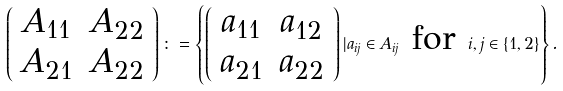Convert formula to latex. <formula><loc_0><loc_0><loc_500><loc_500>\left ( \begin{array} { c c } A _ { 1 1 } & A _ { 2 2 } \\ A _ { 2 1 } & A _ { 2 2 } \end{array} \right ) \colon = \left \{ \left ( \begin{array} { c c } a _ { 1 1 } & a _ { 1 2 } \\ a _ { 2 1 } & a _ { 2 2 } \end{array} \right ) | a _ { i j } \in A _ { i j } \text { for } i , j \in \{ 1 , 2 \} \right \} .</formula> 